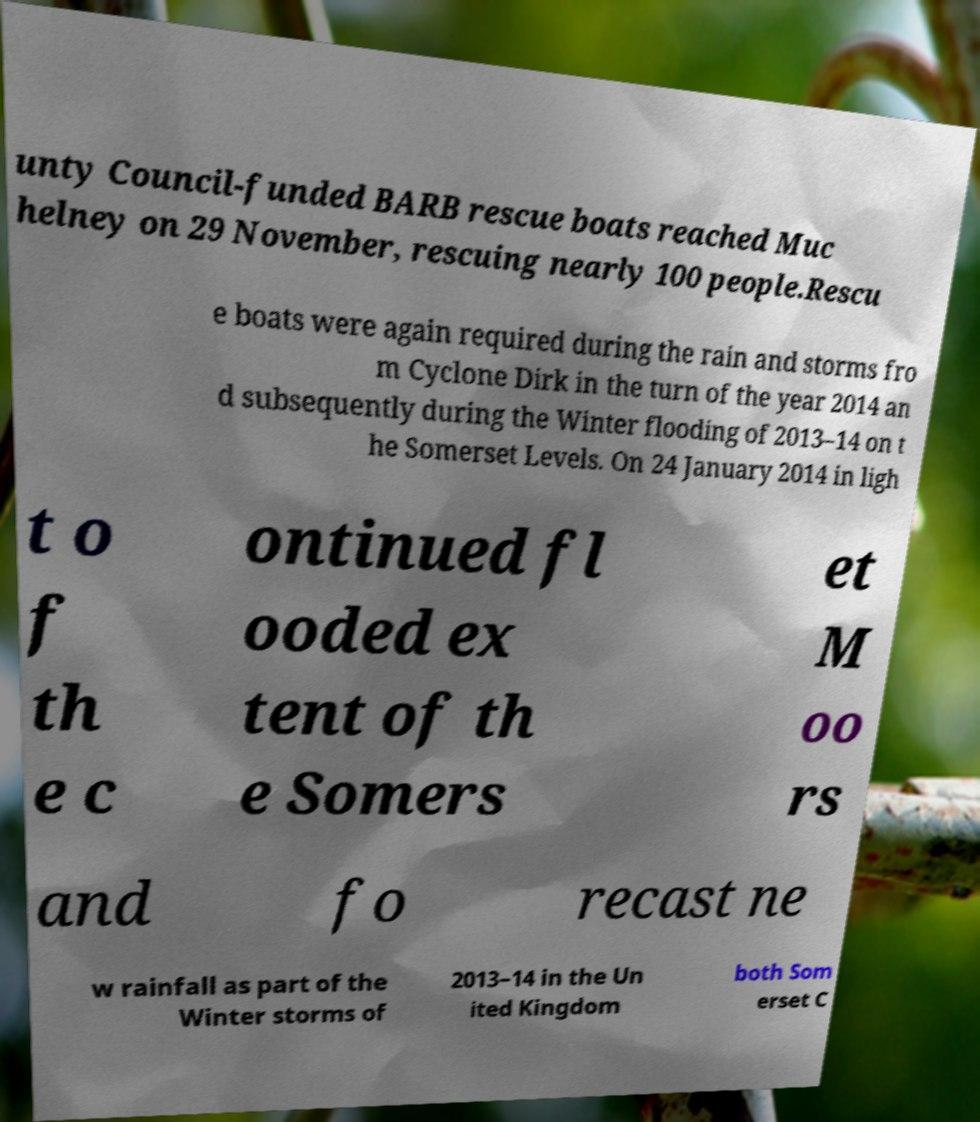Could you assist in decoding the text presented in this image and type it out clearly? unty Council-funded BARB rescue boats reached Muc helney on 29 November, rescuing nearly 100 people.Rescu e boats were again required during the rain and storms fro m Cyclone Dirk in the turn of the year 2014 an d subsequently during the Winter flooding of 2013–14 on t he Somerset Levels. On 24 January 2014 in ligh t o f th e c ontinued fl ooded ex tent of th e Somers et M oo rs and fo recast ne w rainfall as part of the Winter storms of 2013–14 in the Un ited Kingdom both Som erset C 